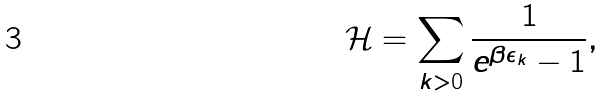<formula> <loc_0><loc_0><loc_500><loc_500>\mathcal { H } = \sum _ { k > 0 } \frac { 1 } { e ^ { \beta \epsilon _ { k } } - 1 } ,</formula> 